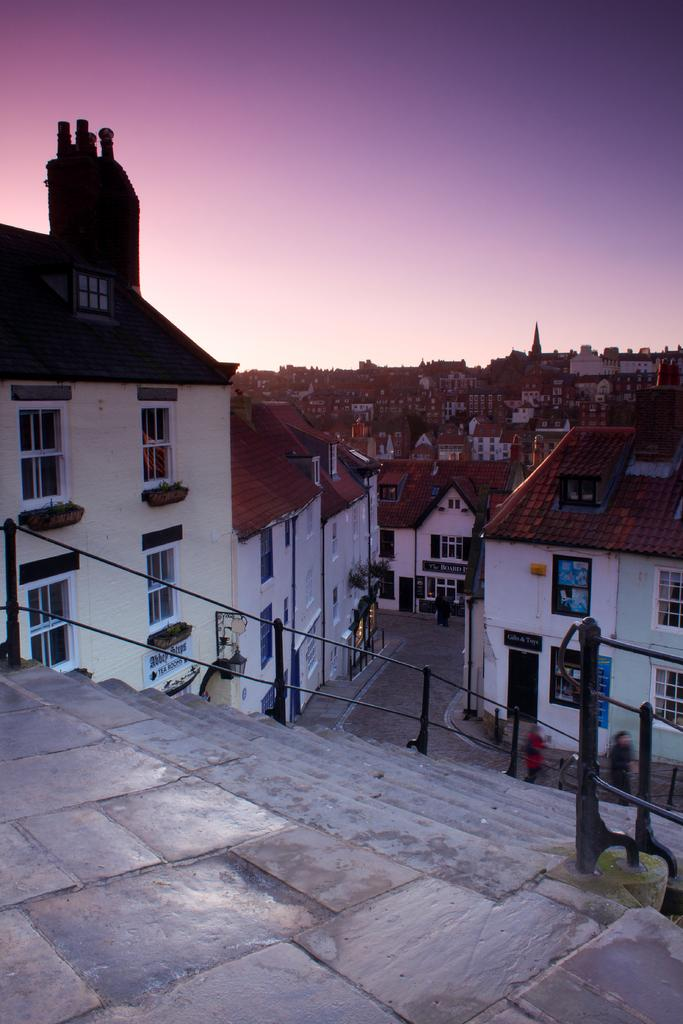What is located at the bottom of the image? There is a staircase at the bottom of the image. What can be seen in the middle of the image? There are houses in the middle of the image. What is visible in the background of the image? The sky is visible in the background of the image. What type of ant can be seen carrying a piece of dinner in the image? There are no ants or dinner present in the image. How many police officers are visible in the image? There are no police officers present in the image. 